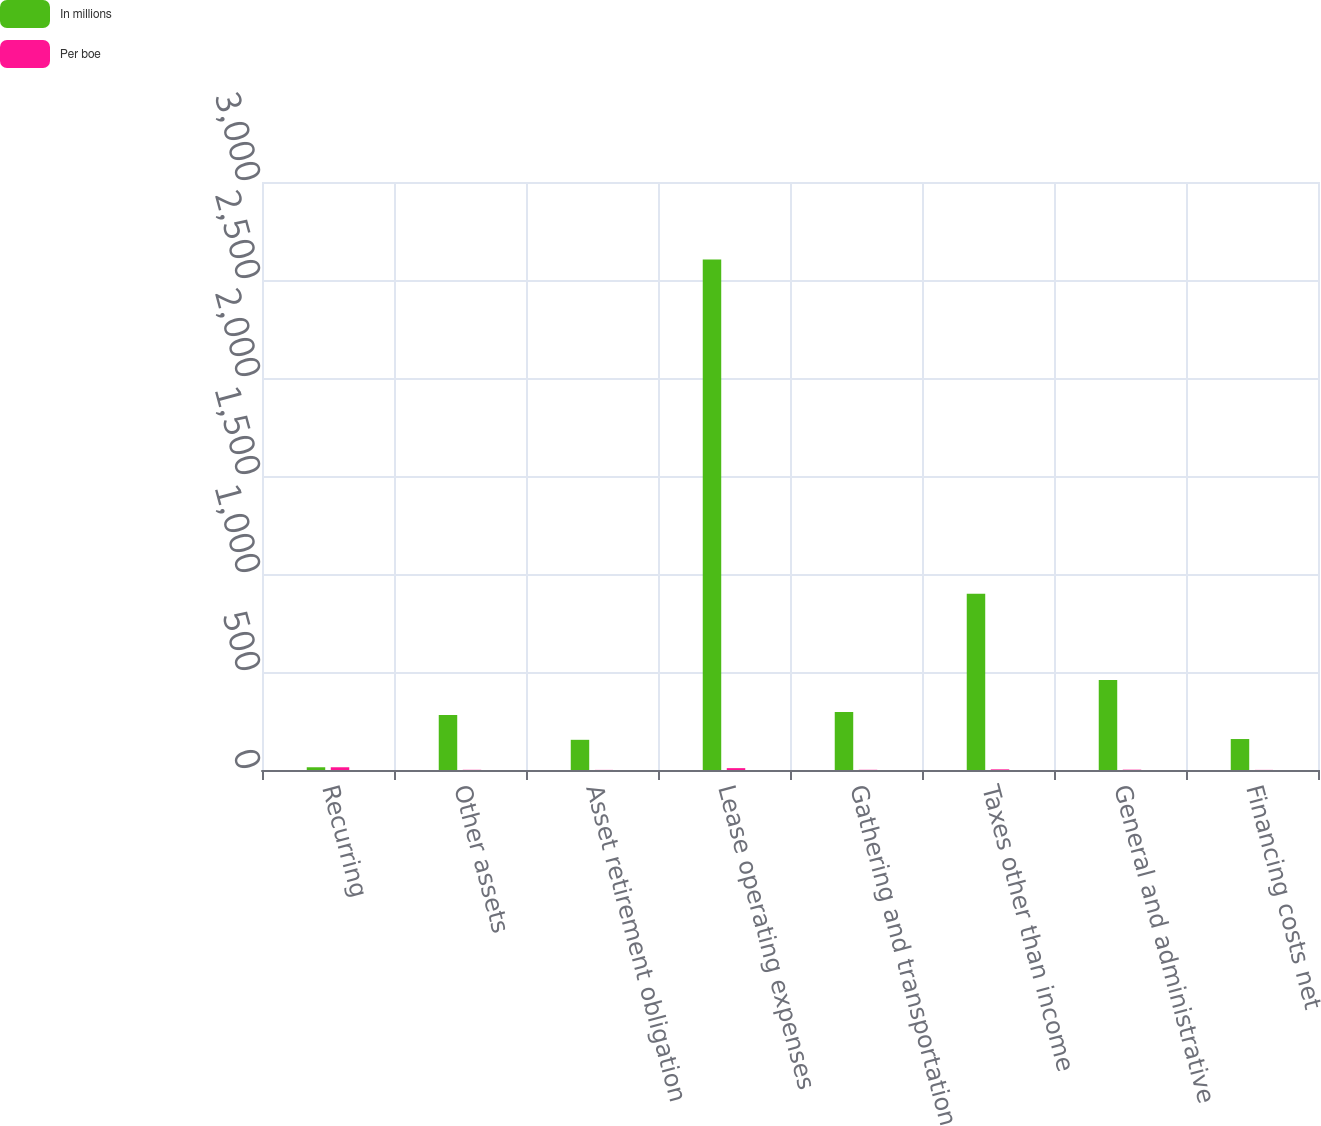<chart> <loc_0><loc_0><loc_500><loc_500><stacked_bar_chart><ecel><fcel>Recurring<fcel>Other assets<fcel>Asset retirement obligation<fcel>Lease operating expenses<fcel>Gathering and transportation<fcel>Taxes other than income<fcel>General and administrative<fcel>Financing costs net<nl><fcel>In millions<fcel>13.97<fcel>281<fcel>154<fcel>2605<fcel>296<fcel>899<fcel>459<fcel>158<nl><fcel>Per boe<fcel>13.97<fcel>1.03<fcel>0.56<fcel>9.54<fcel>1.08<fcel>3.29<fcel>1.68<fcel>0.58<nl></chart> 